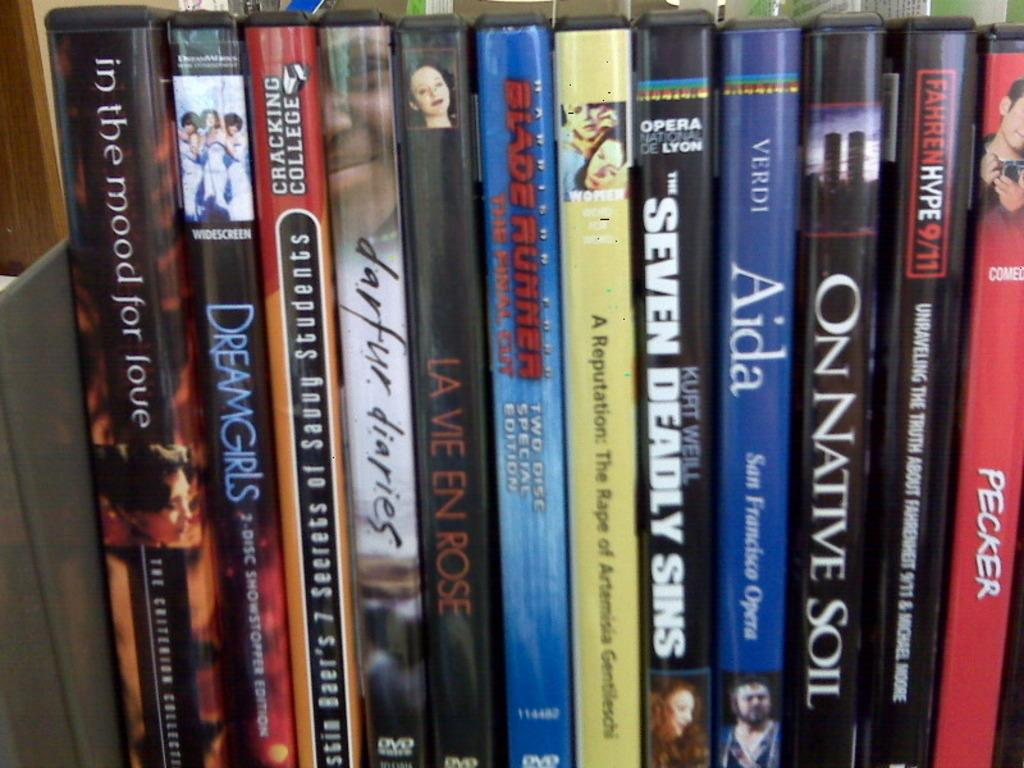What objects are present in the image? There are books in the image. How are the books arranged in the image? The books are arranged in a bookshelf. Can you describe the books that are visible in the background of the image? There are books visible at the top of the image in the background. What type of pancake is being served on the lace tablecloth in the image? There is no pancake or lace tablecloth present in the image; it features books arranged in a bookshelf. 